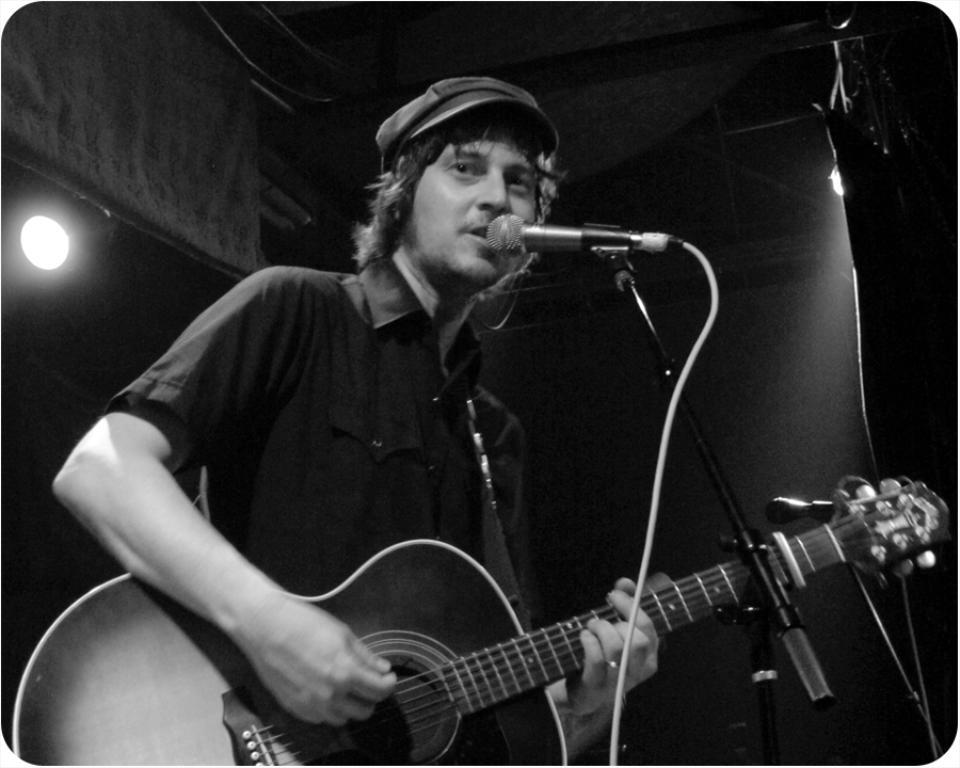What is the person in the image doing? The person is standing and playing a guitar. Can you describe the person's posture in the image? The person is standing while playing the guitar. What can be seen in the background of the image? There are lights in the background. How many beds are visible in the image? There are no beds present in the image. What type of pencil is the person using to play the guitar in the image? The person is not using a pencil to play the guitar in the image; they are using a guitar. 